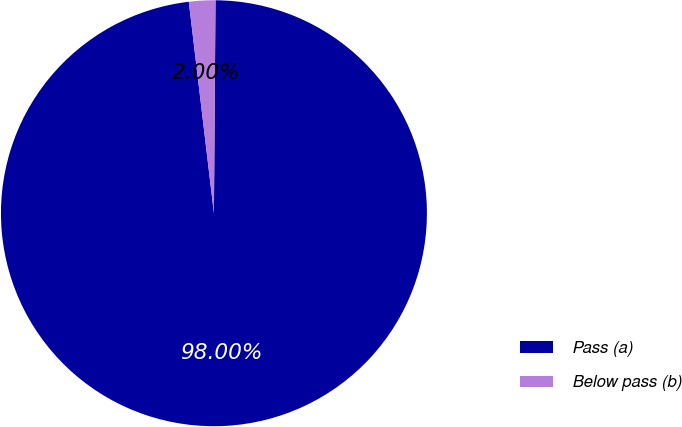<chart> <loc_0><loc_0><loc_500><loc_500><pie_chart><fcel>Pass (a)<fcel>Below pass (b)<nl><fcel>98.0%<fcel>2.0%<nl></chart> 